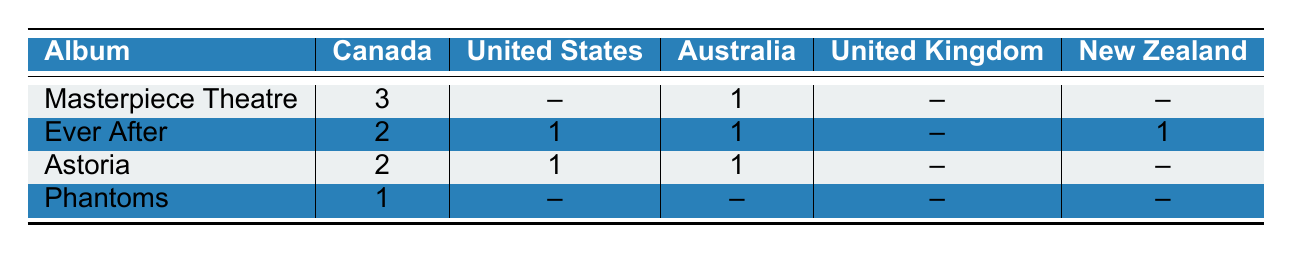What album received the highest certification in Canada? In the table, "Masterpiece Theatre" has the highest certification count of 3 in Canada.
Answer: Masterpiece Theatre How many albums have received certification in the United States? "Ever After" and "Astoria" both received certifications, indicated by the number "1" in the table. Therefore, there are 2 albums with certifications.
Answer: 2 What is the total number of certifications for the album "Ever After"? For "Ever After," the certifications are 2 (Canada) + 1 (United States) + 1 (Australia) + 1 (New Zealand) = 5.
Answer: 5 Did "Phantoms" receive any certifications in Australia? The table shows "Phantoms" with a certification count of 0 in Australia, indicating it did not receive any certifications there.
Answer: No What is the average number of certifications received by the albums in New Zealand? The certifications in New Zealand are 0 (Masterpiece Theatre) + 1 (Ever After) + 0 (Astoria) + 0 (Phantoms) = 1 total certification. Since there are 4 albums, the average is 1/4 = 0.25.
Answer: 0.25 Which album has the least certifications overall, and in which countries did it receive those certifications? "Phantoms" has the least certifications with only 1 in Canada. All other countries show a count of 0.
Answer: Phantoms; Canada How do the certification numbers in Australia compare between "Masterpiece Theatre" and "Astoria"? "Masterpiece Theatre" (1 certification) has the same number as "Astoria" (1 certification) in Australia. Both albums are equal in terms of certifications in that country.
Answer: They are equal How many albums received no certifications in the United Kingdom? From the table, "Masterpiece Theatre," "Ever After," "Astoria," and "Phantoms" all show 0 certifications for the United Kingdom. Therefore, 4 albums received no certifications.
Answer: 4 Is there any album that received a certification in both Canada and New Zealand? Only "Ever After" received certifications in both Canada (2) and New Zealand (1).
Answer: Yes 